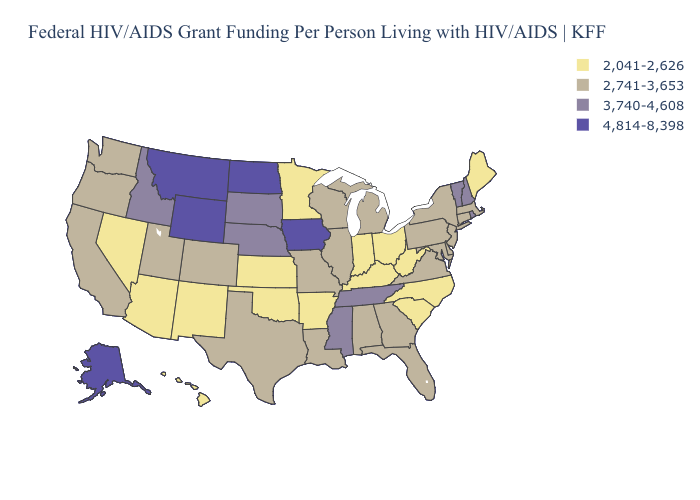What is the value of Mississippi?
Give a very brief answer. 3,740-4,608. What is the value of Kentucky?
Short answer required. 2,041-2,626. Does the map have missing data?
Write a very short answer. No. What is the lowest value in the MidWest?
Concise answer only. 2,041-2,626. What is the value of Minnesota?
Be succinct. 2,041-2,626. Name the states that have a value in the range 2,741-3,653?
Quick response, please. Alabama, California, Colorado, Connecticut, Delaware, Florida, Georgia, Illinois, Louisiana, Maryland, Massachusetts, Michigan, Missouri, New Jersey, New York, Oregon, Pennsylvania, Texas, Utah, Virginia, Washington, Wisconsin. Name the states that have a value in the range 3,740-4,608?
Be succinct. Idaho, Mississippi, Nebraska, New Hampshire, Rhode Island, South Dakota, Tennessee, Vermont. How many symbols are there in the legend?
Be succinct. 4. What is the value of Nevada?
Write a very short answer. 2,041-2,626. Name the states that have a value in the range 4,814-8,398?
Quick response, please. Alaska, Iowa, Montana, North Dakota, Wyoming. Which states have the lowest value in the MidWest?
Keep it brief. Indiana, Kansas, Minnesota, Ohio. What is the value of Kansas?
Give a very brief answer. 2,041-2,626. Name the states that have a value in the range 4,814-8,398?
Short answer required. Alaska, Iowa, Montana, North Dakota, Wyoming. Does Maryland have the lowest value in the USA?
Concise answer only. No. Does the map have missing data?
Keep it brief. No. 